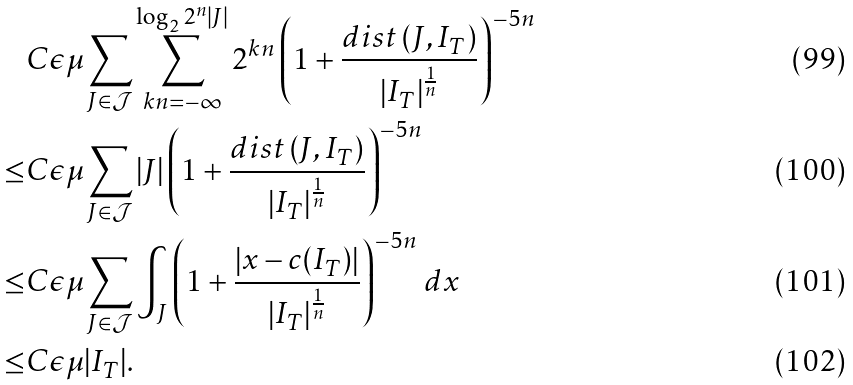<formula> <loc_0><loc_0><loc_500><loc_500>& C \epsilon \mu \sum _ { J \in \mathcal { J } } \sum _ { k n = - \infty } ^ { \log _ { 2 } 2 ^ { n } | J | } 2 ^ { k n } \left ( 1 + \frac { { d i s t } \left ( J , I _ { T } \right ) } { \left | I _ { T } \right | ^ { \frac { 1 } { n } } } \right ) ^ { - 5 n } \\ \leq & C \epsilon \mu \sum _ { J \in \mathcal { J } } | J | \left ( 1 + \frac { { d i s t } \left ( J , I _ { T } \right ) } { \left | I _ { T } \right | ^ { \frac { 1 } { n } } } \right ) ^ { - 5 n } \\ \leq & C \epsilon \mu \sum _ { J \in \mathcal { J } } \int _ { J } \left ( 1 + \frac { \left | { x } - c ( I _ { T } ) \right | } { \left | I _ { T } \right | ^ { \frac { 1 } { n } } } \right ) ^ { - 5 n } \, d { x } \\ \leq & C \epsilon \mu | I _ { T } | .</formula> 